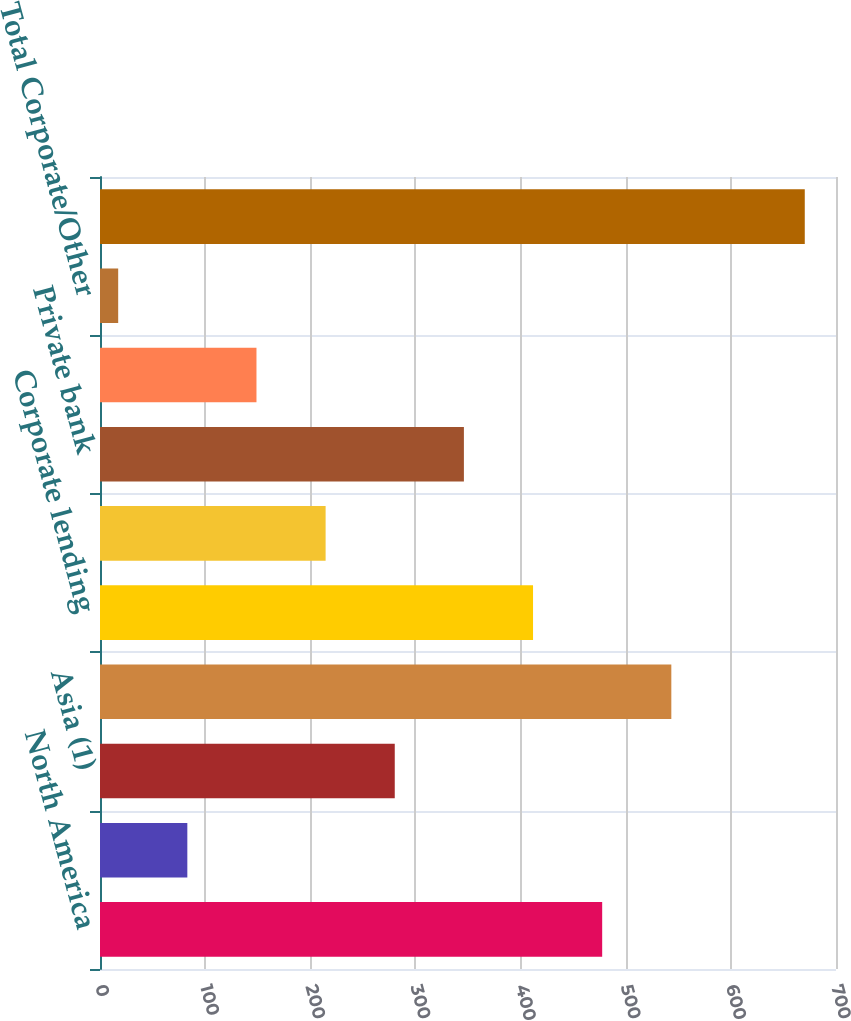<chart> <loc_0><loc_0><loc_500><loc_500><bar_chart><fcel>North America<fcel>Latin America<fcel>Asia (1)<fcel>Total<fcel>Corporate lending<fcel>Treasury and trade solutions<fcel>Private bank<fcel>Markets and securities<fcel>Total Corporate/Other<fcel>Total Citigroup loans (AVG)<nl><fcel>477.62<fcel>83.06<fcel>280.34<fcel>543.38<fcel>411.86<fcel>214.58<fcel>346.1<fcel>148.82<fcel>17.3<fcel>670.3<nl></chart> 